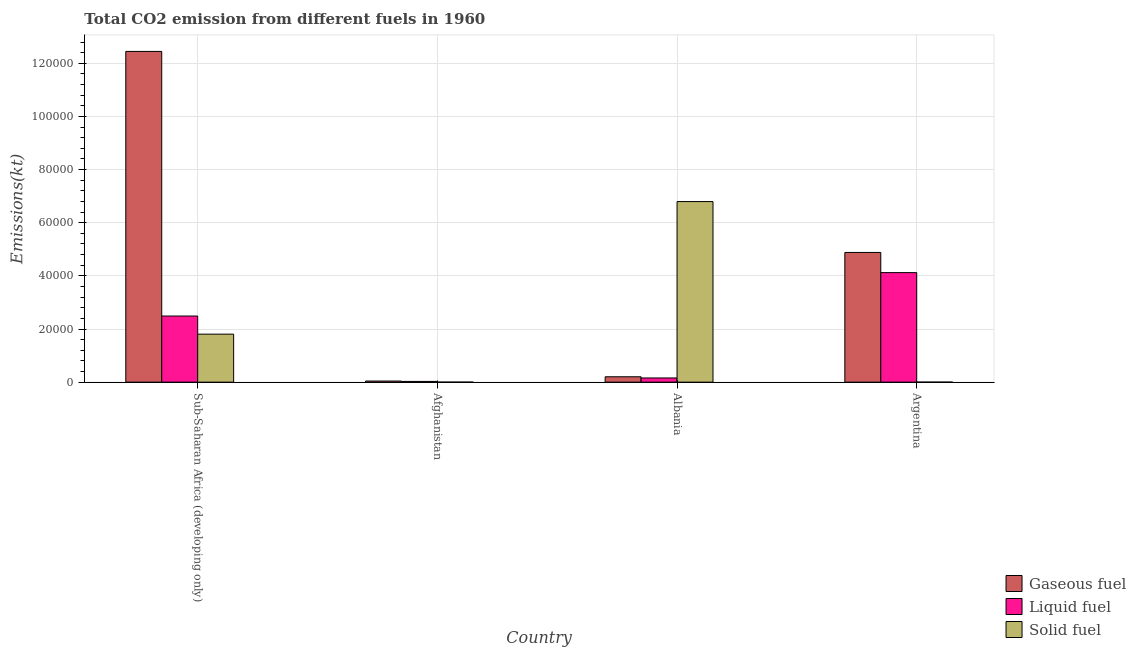How many different coloured bars are there?
Give a very brief answer. 3. How many groups of bars are there?
Make the answer very short. 4. Are the number of bars per tick equal to the number of legend labels?
Give a very brief answer. Yes. Are the number of bars on each tick of the X-axis equal?
Provide a succinct answer. Yes. How many bars are there on the 1st tick from the right?
Make the answer very short. 3. In how many cases, is the number of bars for a given country not equal to the number of legend labels?
Your response must be concise. 0. What is the amount of co2 emissions from liquid fuel in Argentina?
Give a very brief answer. 4.12e+04. Across all countries, what is the maximum amount of co2 emissions from liquid fuel?
Make the answer very short. 4.12e+04. Across all countries, what is the minimum amount of co2 emissions from liquid fuel?
Make the answer very short. 271.36. In which country was the amount of co2 emissions from solid fuel maximum?
Provide a succinct answer. Albania. In which country was the amount of co2 emissions from gaseous fuel minimum?
Keep it short and to the point. Afghanistan. What is the total amount of co2 emissions from gaseous fuel in the graph?
Offer a very short reply. 1.76e+05. What is the difference between the amount of co2 emissions from gaseous fuel in Albania and that in Argentina?
Ensure brevity in your answer.  -4.68e+04. What is the difference between the amount of co2 emissions from solid fuel in Argentina and the amount of co2 emissions from liquid fuel in Albania?
Provide a short and direct response. -1569.48. What is the average amount of co2 emissions from solid fuel per country?
Your response must be concise. 2.15e+04. What is the difference between the amount of co2 emissions from solid fuel and amount of co2 emissions from gaseous fuel in Sub-Saharan Africa (developing only)?
Offer a very short reply. -1.06e+05. In how many countries, is the amount of co2 emissions from liquid fuel greater than 40000 kt?
Provide a short and direct response. 1. What is the ratio of the amount of co2 emissions from liquid fuel in Argentina to that in Sub-Saharan Africa (developing only)?
Keep it short and to the point. 1.66. Is the amount of co2 emissions from solid fuel in Afghanistan less than that in Sub-Saharan Africa (developing only)?
Give a very brief answer. Yes. Is the difference between the amount of co2 emissions from gaseous fuel in Albania and Sub-Saharan Africa (developing only) greater than the difference between the amount of co2 emissions from solid fuel in Albania and Sub-Saharan Africa (developing only)?
Your response must be concise. No. What is the difference between the highest and the second highest amount of co2 emissions from solid fuel?
Ensure brevity in your answer.  4.99e+04. What is the difference between the highest and the lowest amount of co2 emissions from solid fuel?
Offer a terse response. 6.80e+04. What does the 1st bar from the left in Afghanistan represents?
Make the answer very short. Gaseous fuel. What does the 3rd bar from the right in Afghanistan represents?
Your response must be concise. Gaseous fuel. Is it the case that in every country, the sum of the amount of co2 emissions from gaseous fuel and amount of co2 emissions from liquid fuel is greater than the amount of co2 emissions from solid fuel?
Provide a succinct answer. No. How many bars are there?
Offer a very short reply. 12. What is the difference between two consecutive major ticks on the Y-axis?
Ensure brevity in your answer.  2.00e+04. Does the graph contain any zero values?
Offer a terse response. No. Does the graph contain grids?
Your answer should be very brief. Yes. What is the title of the graph?
Offer a very short reply. Total CO2 emission from different fuels in 1960. Does "Renewable sources" appear as one of the legend labels in the graph?
Offer a very short reply. No. What is the label or title of the X-axis?
Keep it short and to the point. Country. What is the label or title of the Y-axis?
Keep it short and to the point. Emissions(kt). What is the Emissions(kt) of Gaseous fuel in Sub-Saharan Africa (developing only)?
Keep it short and to the point. 1.24e+05. What is the Emissions(kt) of Liquid fuel in Sub-Saharan Africa (developing only)?
Give a very brief answer. 2.49e+04. What is the Emissions(kt) of Solid fuel in Sub-Saharan Africa (developing only)?
Your answer should be very brief. 1.81e+04. What is the Emissions(kt) in Gaseous fuel in Afghanistan?
Give a very brief answer. 414.37. What is the Emissions(kt) in Liquid fuel in Afghanistan?
Offer a very short reply. 271.36. What is the Emissions(kt) of Solid fuel in Afghanistan?
Offer a very short reply. 3.67. What is the Emissions(kt) of Gaseous fuel in Albania?
Provide a succinct answer. 2024.18. What is the Emissions(kt) in Liquid fuel in Albania?
Your answer should be compact. 1576.81. What is the Emissions(kt) in Solid fuel in Albania?
Provide a succinct answer. 6.80e+04. What is the Emissions(kt) of Gaseous fuel in Argentina?
Your response must be concise. 4.88e+04. What is the Emissions(kt) in Liquid fuel in Argentina?
Provide a succinct answer. 4.12e+04. What is the Emissions(kt) of Solid fuel in Argentina?
Ensure brevity in your answer.  7.33. Across all countries, what is the maximum Emissions(kt) of Gaseous fuel?
Offer a very short reply. 1.24e+05. Across all countries, what is the maximum Emissions(kt) of Liquid fuel?
Ensure brevity in your answer.  4.12e+04. Across all countries, what is the maximum Emissions(kt) of Solid fuel?
Your answer should be compact. 6.80e+04. Across all countries, what is the minimum Emissions(kt) in Gaseous fuel?
Your response must be concise. 414.37. Across all countries, what is the minimum Emissions(kt) of Liquid fuel?
Offer a very short reply. 271.36. Across all countries, what is the minimum Emissions(kt) in Solid fuel?
Your response must be concise. 3.67. What is the total Emissions(kt) of Gaseous fuel in the graph?
Ensure brevity in your answer.  1.76e+05. What is the total Emissions(kt) of Liquid fuel in the graph?
Offer a very short reply. 6.80e+04. What is the total Emissions(kt) in Solid fuel in the graph?
Your response must be concise. 8.60e+04. What is the difference between the Emissions(kt) of Gaseous fuel in Sub-Saharan Africa (developing only) and that in Afghanistan?
Keep it short and to the point. 1.24e+05. What is the difference between the Emissions(kt) in Liquid fuel in Sub-Saharan Africa (developing only) and that in Afghanistan?
Offer a very short reply. 2.46e+04. What is the difference between the Emissions(kt) of Solid fuel in Sub-Saharan Africa (developing only) and that in Afghanistan?
Offer a very short reply. 1.81e+04. What is the difference between the Emissions(kt) of Gaseous fuel in Sub-Saharan Africa (developing only) and that in Albania?
Ensure brevity in your answer.  1.22e+05. What is the difference between the Emissions(kt) of Liquid fuel in Sub-Saharan Africa (developing only) and that in Albania?
Your answer should be very brief. 2.33e+04. What is the difference between the Emissions(kt) in Solid fuel in Sub-Saharan Africa (developing only) and that in Albania?
Keep it short and to the point. -4.99e+04. What is the difference between the Emissions(kt) in Gaseous fuel in Sub-Saharan Africa (developing only) and that in Argentina?
Your answer should be very brief. 7.57e+04. What is the difference between the Emissions(kt) in Liquid fuel in Sub-Saharan Africa (developing only) and that in Argentina?
Provide a short and direct response. -1.63e+04. What is the difference between the Emissions(kt) in Solid fuel in Sub-Saharan Africa (developing only) and that in Argentina?
Your answer should be very brief. 1.81e+04. What is the difference between the Emissions(kt) in Gaseous fuel in Afghanistan and that in Albania?
Your response must be concise. -1609.81. What is the difference between the Emissions(kt) of Liquid fuel in Afghanistan and that in Albania?
Your response must be concise. -1305.45. What is the difference between the Emissions(kt) in Solid fuel in Afghanistan and that in Albania?
Make the answer very short. -6.80e+04. What is the difference between the Emissions(kt) in Gaseous fuel in Afghanistan and that in Argentina?
Offer a very short reply. -4.84e+04. What is the difference between the Emissions(kt) of Liquid fuel in Afghanistan and that in Argentina?
Give a very brief answer. -4.10e+04. What is the difference between the Emissions(kt) in Solid fuel in Afghanistan and that in Argentina?
Keep it short and to the point. -3.67. What is the difference between the Emissions(kt) in Gaseous fuel in Albania and that in Argentina?
Offer a terse response. -4.68e+04. What is the difference between the Emissions(kt) of Liquid fuel in Albania and that in Argentina?
Make the answer very short. -3.96e+04. What is the difference between the Emissions(kt) in Solid fuel in Albania and that in Argentina?
Make the answer very short. 6.80e+04. What is the difference between the Emissions(kt) in Gaseous fuel in Sub-Saharan Africa (developing only) and the Emissions(kt) in Liquid fuel in Afghanistan?
Make the answer very short. 1.24e+05. What is the difference between the Emissions(kt) in Gaseous fuel in Sub-Saharan Africa (developing only) and the Emissions(kt) in Solid fuel in Afghanistan?
Keep it short and to the point. 1.24e+05. What is the difference between the Emissions(kt) in Liquid fuel in Sub-Saharan Africa (developing only) and the Emissions(kt) in Solid fuel in Afghanistan?
Provide a succinct answer. 2.49e+04. What is the difference between the Emissions(kt) in Gaseous fuel in Sub-Saharan Africa (developing only) and the Emissions(kt) in Liquid fuel in Albania?
Make the answer very short. 1.23e+05. What is the difference between the Emissions(kt) of Gaseous fuel in Sub-Saharan Africa (developing only) and the Emissions(kt) of Solid fuel in Albania?
Your answer should be very brief. 5.65e+04. What is the difference between the Emissions(kt) of Liquid fuel in Sub-Saharan Africa (developing only) and the Emissions(kt) of Solid fuel in Albania?
Your answer should be very brief. -4.31e+04. What is the difference between the Emissions(kt) in Gaseous fuel in Sub-Saharan Africa (developing only) and the Emissions(kt) in Liquid fuel in Argentina?
Ensure brevity in your answer.  8.33e+04. What is the difference between the Emissions(kt) in Gaseous fuel in Sub-Saharan Africa (developing only) and the Emissions(kt) in Solid fuel in Argentina?
Give a very brief answer. 1.24e+05. What is the difference between the Emissions(kt) of Liquid fuel in Sub-Saharan Africa (developing only) and the Emissions(kt) of Solid fuel in Argentina?
Ensure brevity in your answer.  2.49e+04. What is the difference between the Emissions(kt) in Gaseous fuel in Afghanistan and the Emissions(kt) in Liquid fuel in Albania?
Offer a very short reply. -1162.44. What is the difference between the Emissions(kt) in Gaseous fuel in Afghanistan and the Emissions(kt) in Solid fuel in Albania?
Your answer should be very brief. -6.75e+04. What is the difference between the Emissions(kt) of Liquid fuel in Afghanistan and the Emissions(kt) of Solid fuel in Albania?
Provide a short and direct response. -6.77e+04. What is the difference between the Emissions(kt) in Gaseous fuel in Afghanistan and the Emissions(kt) in Liquid fuel in Argentina?
Offer a terse response. -4.08e+04. What is the difference between the Emissions(kt) of Gaseous fuel in Afghanistan and the Emissions(kt) of Solid fuel in Argentina?
Provide a short and direct response. 407.04. What is the difference between the Emissions(kt) in Liquid fuel in Afghanistan and the Emissions(kt) in Solid fuel in Argentina?
Your response must be concise. 264.02. What is the difference between the Emissions(kt) of Gaseous fuel in Albania and the Emissions(kt) of Liquid fuel in Argentina?
Your answer should be very brief. -3.92e+04. What is the difference between the Emissions(kt) in Gaseous fuel in Albania and the Emissions(kt) in Solid fuel in Argentina?
Provide a short and direct response. 2016.85. What is the difference between the Emissions(kt) of Liquid fuel in Albania and the Emissions(kt) of Solid fuel in Argentina?
Make the answer very short. 1569.48. What is the average Emissions(kt) in Gaseous fuel per country?
Your answer should be very brief. 4.39e+04. What is the average Emissions(kt) in Liquid fuel per country?
Your response must be concise. 1.70e+04. What is the average Emissions(kt) in Solid fuel per country?
Give a very brief answer. 2.15e+04. What is the difference between the Emissions(kt) in Gaseous fuel and Emissions(kt) in Liquid fuel in Sub-Saharan Africa (developing only)?
Offer a very short reply. 9.96e+04. What is the difference between the Emissions(kt) in Gaseous fuel and Emissions(kt) in Solid fuel in Sub-Saharan Africa (developing only)?
Your response must be concise. 1.06e+05. What is the difference between the Emissions(kt) of Liquid fuel and Emissions(kt) of Solid fuel in Sub-Saharan Africa (developing only)?
Ensure brevity in your answer.  6822.35. What is the difference between the Emissions(kt) of Gaseous fuel and Emissions(kt) of Liquid fuel in Afghanistan?
Keep it short and to the point. 143.01. What is the difference between the Emissions(kt) in Gaseous fuel and Emissions(kt) in Solid fuel in Afghanistan?
Provide a short and direct response. 410.7. What is the difference between the Emissions(kt) in Liquid fuel and Emissions(kt) in Solid fuel in Afghanistan?
Your answer should be very brief. 267.69. What is the difference between the Emissions(kt) in Gaseous fuel and Emissions(kt) in Liquid fuel in Albania?
Give a very brief answer. 447.37. What is the difference between the Emissions(kt) in Gaseous fuel and Emissions(kt) in Solid fuel in Albania?
Ensure brevity in your answer.  -6.59e+04. What is the difference between the Emissions(kt) of Liquid fuel and Emissions(kt) of Solid fuel in Albania?
Give a very brief answer. -6.64e+04. What is the difference between the Emissions(kt) of Gaseous fuel and Emissions(kt) of Liquid fuel in Argentina?
Provide a succinct answer. 7590.69. What is the difference between the Emissions(kt) in Gaseous fuel and Emissions(kt) in Solid fuel in Argentina?
Your response must be concise. 4.88e+04. What is the difference between the Emissions(kt) in Liquid fuel and Emissions(kt) in Solid fuel in Argentina?
Give a very brief answer. 4.12e+04. What is the ratio of the Emissions(kt) in Gaseous fuel in Sub-Saharan Africa (developing only) to that in Afghanistan?
Your response must be concise. 300.4. What is the ratio of the Emissions(kt) of Liquid fuel in Sub-Saharan Africa (developing only) to that in Afghanistan?
Make the answer very short. 91.71. What is the ratio of the Emissions(kt) in Solid fuel in Sub-Saharan Africa (developing only) to that in Afghanistan?
Offer a very short reply. 4926. What is the ratio of the Emissions(kt) of Gaseous fuel in Sub-Saharan Africa (developing only) to that in Albania?
Provide a succinct answer. 61.49. What is the ratio of the Emissions(kt) in Liquid fuel in Sub-Saharan Africa (developing only) to that in Albania?
Your response must be concise. 15.78. What is the ratio of the Emissions(kt) of Solid fuel in Sub-Saharan Africa (developing only) to that in Albania?
Your response must be concise. 0.27. What is the ratio of the Emissions(kt) of Gaseous fuel in Sub-Saharan Africa (developing only) to that in Argentina?
Keep it short and to the point. 2.55. What is the ratio of the Emissions(kt) of Liquid fuel in Sub-Saharan Africa (developing only) to that in Argentina?
Provide a succinct answer. 0.6. What is the ratio of the Emissions(kt) in Solid fuel in Sub-Saharan Africa (developing only) to that in Argentina?
Your response must be concise. 2463. What is the ratio of the Emissions(kt) of Gaseous fuel in Afghanistan to that in Albania?
Give a very brief answer. 0.2. What is the ratio of the Emissions(kt) in Liquid fuel in Afghanistan to that in Albania?
Offer a terse response. 0.17. What is the ratio of the Emissions(kt) in Gaseous fuel in Afghanistan to that in Argentina?
Offer a very short reply. 0.01. What is the ratio of the Emissions(kt) in Liquid fuel in Afghanistan to that in Argentina?
Your response must be concise. 0.01. What is the ratio of the Emissions(kt) of Solid fuel in Afghanistan to that in Argentina?
Your answer should be compact. 0.5. What is the ratio of the Emissions(kt) in Gaseous fuel in Albania to that in Argentina?
Give a very brief answer. 0.04. What is the ratio of the Emissions(kt) in Liquid fuel in Albania to that in Argentina?
Give a very brief answer. 0.04. What is the ratio of the Emissions(kt) in Solid fuel in Albania to that in Argentina?
Offer a very short reply. 9266.5. What is the difference between the highest and the second highest Emissions(kt) in Gaseous fuel?
Your response must be concise. 7.57e+04. What is the difference between the highest and the second highest Emissions(kt) of Liquid fuel?
Your answer should be very brief. 1.63e+04. What is the difference between the highest and the second highest Emissions(kt) in Solid fuel?
Ensure brevity in your answer.  4.99e+04. What is the difference between the highest and the lowest Emissions(kt) in Gaseous fuel?
Ensure brevity in your answer.  1.24e+05. What is the difference between the highest and the lowest Emissions(kt) of Liquid fuel?
Your answer should be very brief. 4.10e+04. What is the difference between the highest and the lowest Emissions(kt) in Solid fuel?
Give a very brief answer. 6.80e+04. 